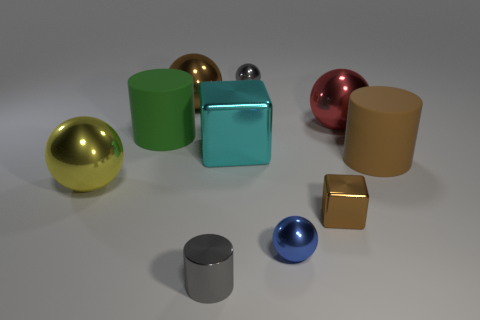Subtract all big brown matte cylinders. How many cylinders are left? 2 Subtract all gray cylinders. How many cylinders are left? 2 Subtract 1 brown cylinders. How many objects are left? 9 Subtract all cubes. How many objects are left? 8 Subtract 2 cylinders. How many cylinders are left? 1 Subtract all purple blocks. Subtract all blue balls. How many blocks are left? 2 Subtract all purple cylinders. How many blue blocks are left? 0 Subtract all small brown rubber cylinders. Subtract all blue spheres. How many objects are left? 9 Add 4 tiny brown metal things. How many tiny brown metal things are left? 5 Add 10 big purple matte balls. How many big purple matte balls exist? 10 